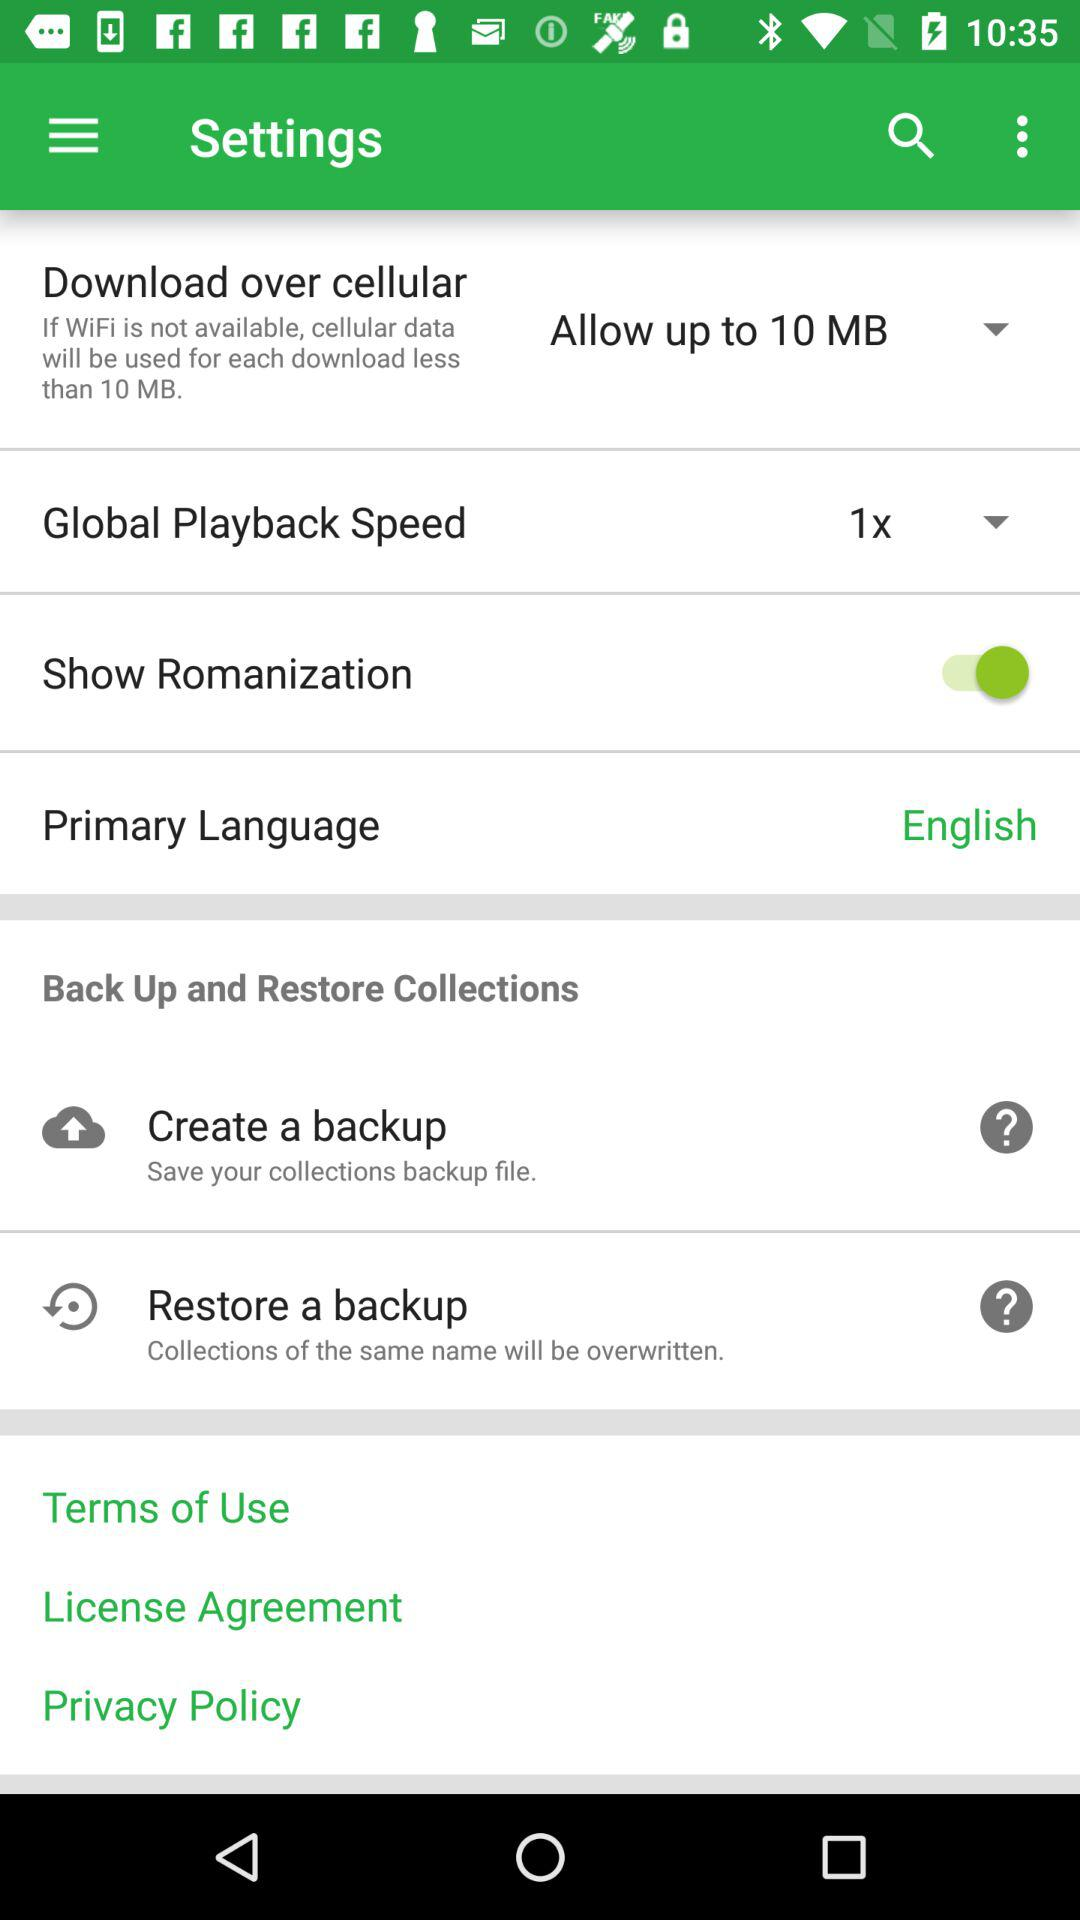What is the speed of global playback? The speed of global playback is 1x. 